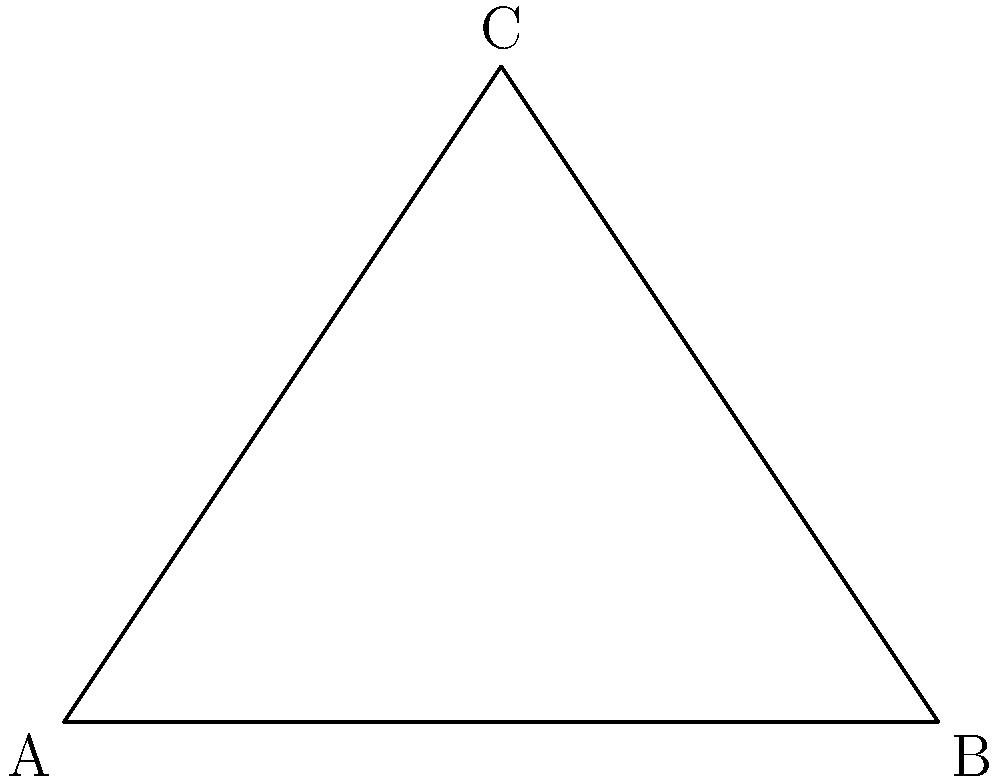You're designing a trellis for your climbing roses, considering the sun's angle changes throughout the year. If the trellis is 100 cm wide at the base and needs to be 75 cm high for optimal sun exposure, what angle should it form with the ground to provide the best support for the roses? Let's approach this step-by-step:

1) We can treat the trellis as a right-angled triangle, where:
   - The base (width) is 100 cm
   - The height is 75 cm
   - We need to find the angle it forms with the ground

2) In a right-angled triangle, we can use the tangent function to find this angle.

3) The tangent of an angle is the ratio of the opposite side to the adjacent side.
   
   $\tan(\theta) = \frac{\text{opposite}}{\text{adjacent}} = \frac{\text{height}}{\text{base/2}}$

4) We divide the base by 2 because we want the angle from the ground to the middle of the trellis.

5) Plugging in our values:

   $\tan(\theta) = \frac{75}{\frac{100}{2}} = \frac{75}{50} = 1.5$

6) To find the angle, we need to use the inverse tangent (arctan or $\tan^{-1}$):

   $\theta = \tan^{-1}(1.5)$

7) Using a calculator or mathematical tables:

   $\theta \approx 56.3°$

Therefore, the trellis should form an angle of approximately 56.3° with the ground to provide the best support for the climbing roses while considering optimal sun exposure.
Answer: 56.3° 